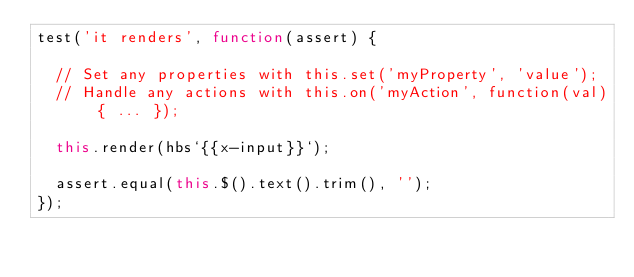Convert code to text. <code><loc_0><loc_0><loc_500><loc_500><_JavaScript_>test('it renders', function(assert) {

  // Set any properties with this.set('myProperty', 'value');
  // Handle any actions with this.on('myAction', function(val) { ... });

  this.render(hbs`{{x-input}}`);

  assert.equal(this.$().text().trim(), '');
});</code> 